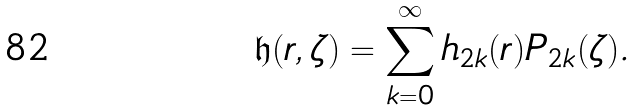Convert formula to latex. <formula><loc_0><loc_0><loc_500><loc_500>\mathfrak { h } ( r , \zeta ) = \sum _ { k = 0 } ^ { \infty } h _ { 2 k } ( r ) P _ { 2 k } ( \zeta ) .</formula> 